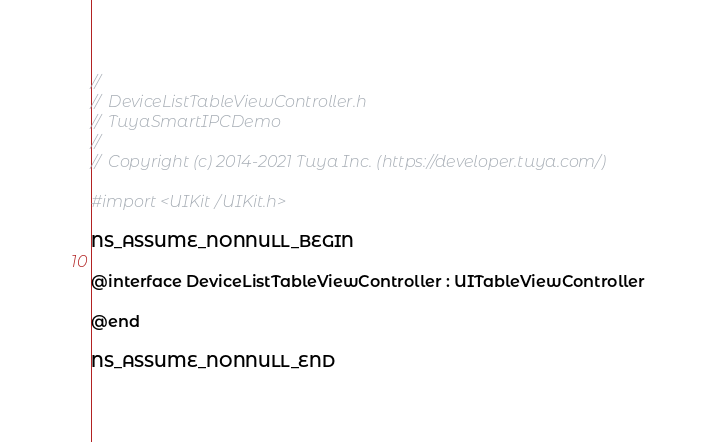<code> <loc_0><loc_0><loc_500><loc_500><_C_>//
//  DeviceListTableViewController.h
//  TuyaSmartIPCDemo
//
//  Copyright (c) 2014-2021 Tuya Inc. (https://developer.tuya.com/)

#import <UIKit/UIKit.h>

NS_ASSUME_NONNULL_BEGIN

@interface DeviceListTableViewController : UITableViewController

@end

NS_ASSUME_NONNULL_END
</code> 